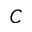<formula> <loc_0><loc_0><loc_500><loc_500>C</formula> 